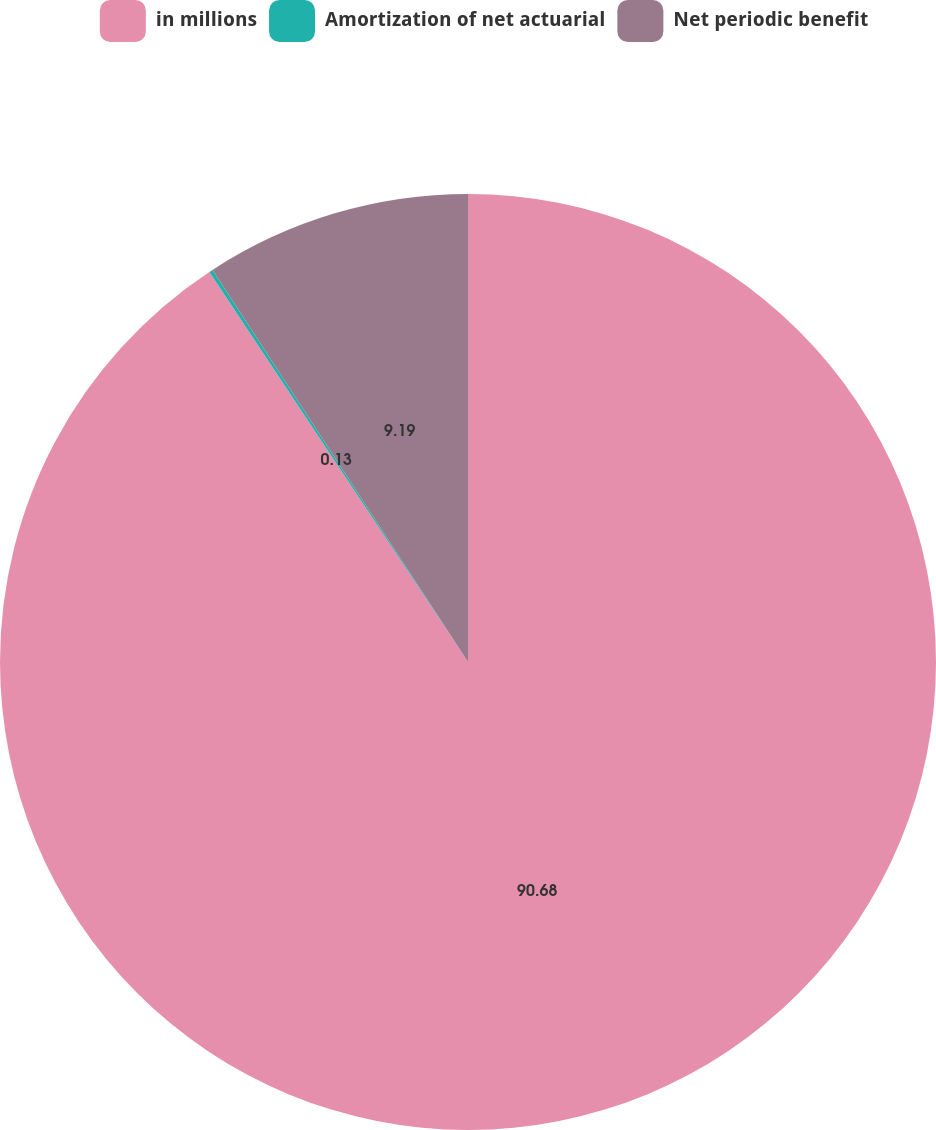Convert chart. <chart><loc_0><loc_0><loc_500><loc_500><pie_chart><fcel>in millions<fcel>Amortization of net actuarial<fcel>Net periodic benefit<nl><fcel>90.68%<fcel>0.13%<fcel>9.19%<nl></chart> 